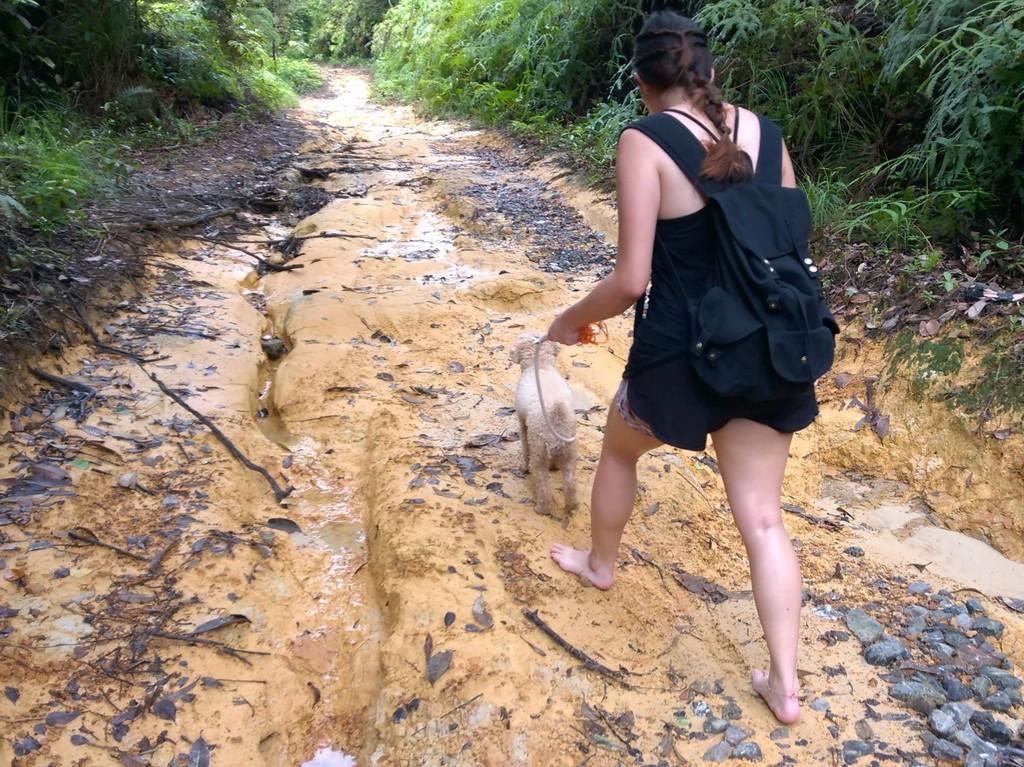What is the main subject of the image? The main subject of the image is a woman. What is the woman holding in the image? The woman is holding a dog. What type of vegetation is present in the image? There are plants in the image. What type of natural elements can be seen in the image? There are stones and sand in the image. What type of wood is the woman using to read her income statement in the image? There is no wood or income statement present in the image. What type of book is the woman reading in the image? There is no book or reading activity depicted in the image. 